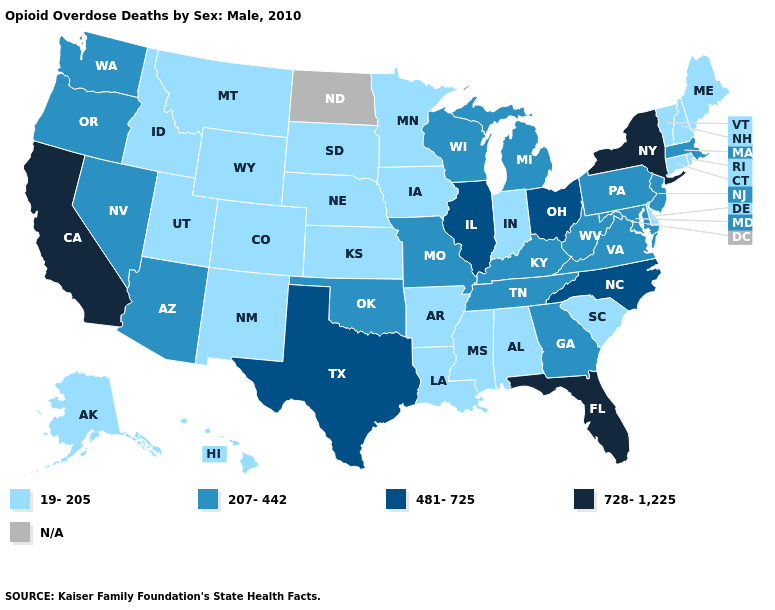Which states have the highest value in the USA?
Be succinct. California, Florida, New York. Which states have the highest value in the USA?
Quick response, please. California, Florida, New York. Does New York have the highest value in the Northeast?
Short answer required. Yes. What is the value of West Virginia?
Concise answer only. 207-442. Does Nevada have the highest value in the USA?
Concise answer only. No. What is the value of Missouri?
Give a very brief answer. 207-442. What is the lowest value in the West?
Answer briefly. 19-205. Name the states that have a value in the range 19-205?
Quick response, please. Alabama, Alaska, Arkansas, Colorado, Connecticut, Delaware, Hawaii, Idaho, Indiana, Iowa, Kansas, Louisiana, Maine, Minnesota, Mississippi, Montana, Nebraska, New Hampshire, New Mexico, Rhode Island, South Carolina, South Dakota, Utah, Vermont, Wyoming. Name the states that have a value in the range 19-205?
Short answer required. Alabama, Alaska, Arkansas, Colorado, Connecticut, Delaware, Hawaii, Idaho, Indiana, Iowa, Kansas, Louisiana, Maine, Minnesota, Mississippi, Montana, Nebraska, New Hampshire, New Mexico, Rhode Island, South Carolina, South Dakota, Utah, Vermont, Wyoming. Is the legend a continuous bar?
Give a very brief answer. No. Among the states that border Iowa , which have the highest value?
Be succinct. Illinois. What is the value of Virginia?
Answer briefly. 207-442. Among the states that border Ohio , which have the lowest value?
Answer briefly. Indiana. Name the states that have a value in the range 207-442?
Be succinct. Arizona, Georgia, Kentucky, Maryland, Massachusetts, Michigan, Missouri, Nevada, New Jersey, Oklahoma, Oregon, Pennsylvania, Tennessee, Virginia, Washington, West Virginia, Wisconsin. 